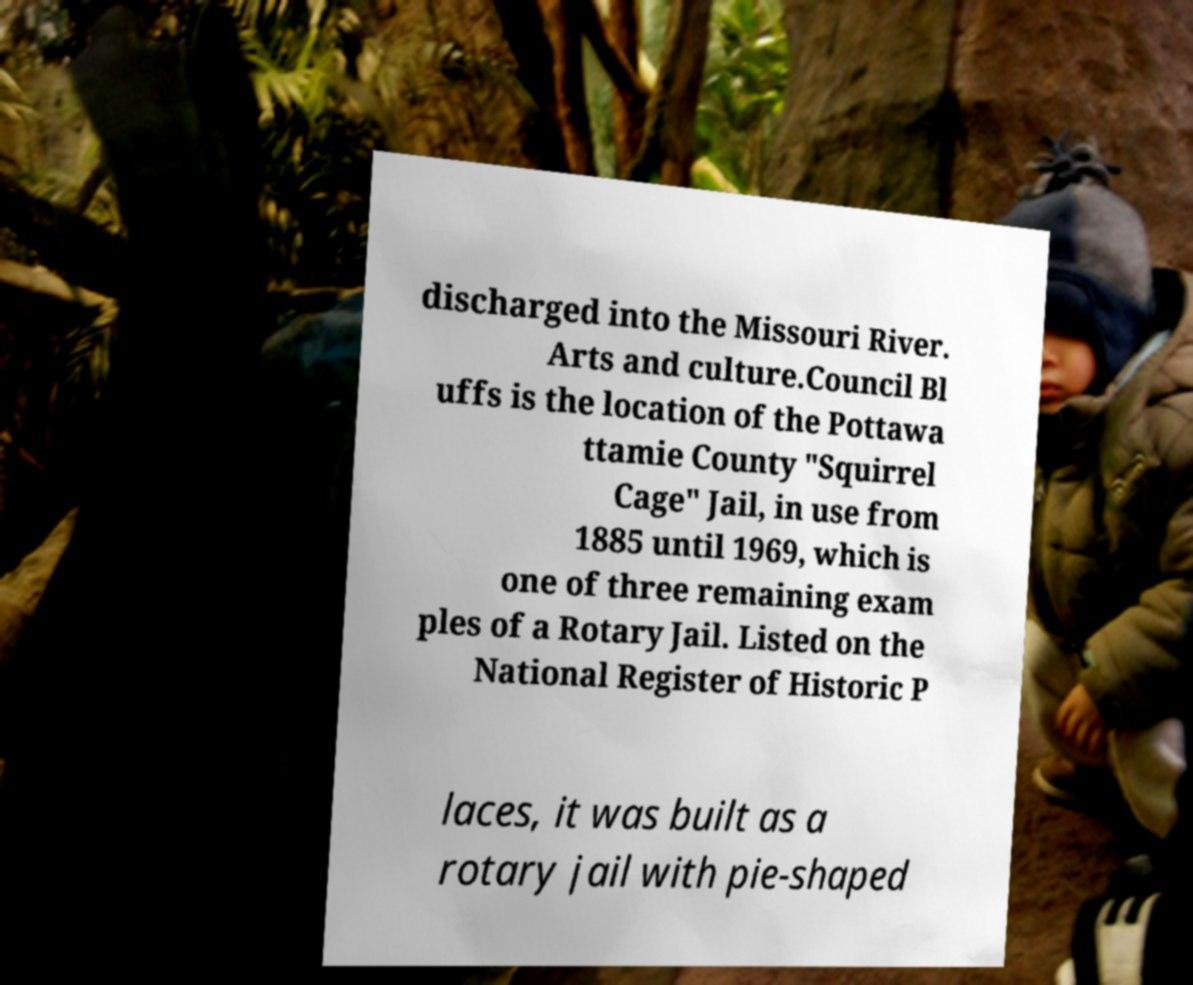I need the written content from this picture converted into text. Can you do that? discharged into the Missouri River. Arts and culture.Council Bl uffs is the location of the Pottawa ttamie County "Squirrel Cage" Jail, in use from 1885 until 1969, which is one of three remaining exam ples of a Rotary Jail. Listed on the National Register of Historic P laces, it was built as a rotary jail with pie-shaped 